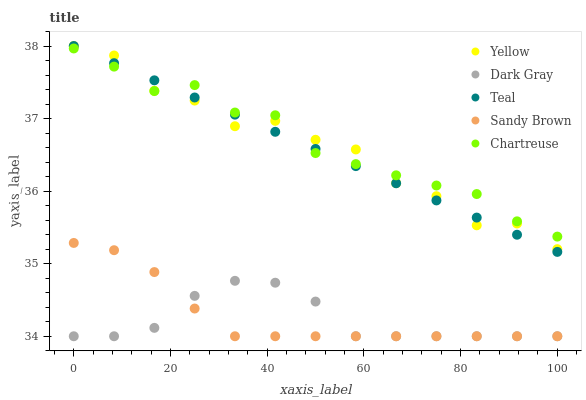Does Dark Gray have the minimum area under the curve?
Answer yes or no. Yes. Does Chartreuse have the maximum area under the curve?
Answer yes or no. Yes. Does Sandy Brown have the minimum area under the curve?
Answer yes or no. No. Does Sandy Brown have the maximum area under the curve?
Answer yes or no. No. Is Teal the smoothest?
Answer yes or no. Yes. Is Yellow the roughest?
Answer yes or no. Yes. Is Chartreuse the smoothest?
Answer yes or no. No. Is Chartreuse the roughest?
Answer yes or no. No. Does Dark Gray have the lowest value?
Answer yes or no. Yes. Does Chartreuse have the lowest value?
Answer yes or no. No. Does Yellow have the highest value?
Answer yes or no. Yes. Does Chartreuse have the highest value?
Answer yes or no. No. Is Sandy Brown less than Chartreuse?
Answer yes or no. Yes. Is Yellow greater than Sandy Brown?
Answer yes or no. Yes. Does Chartreuse intersect Yellow?
Answer yes or no. Yes. Is Chartreuse less than Yellow?
Answer yes or no. No. Is Chartreuse greater than Yellow?
Answer yes or no. No. Does Sandy Brown intersect Chartreuse?
Answer yes or no. No. 